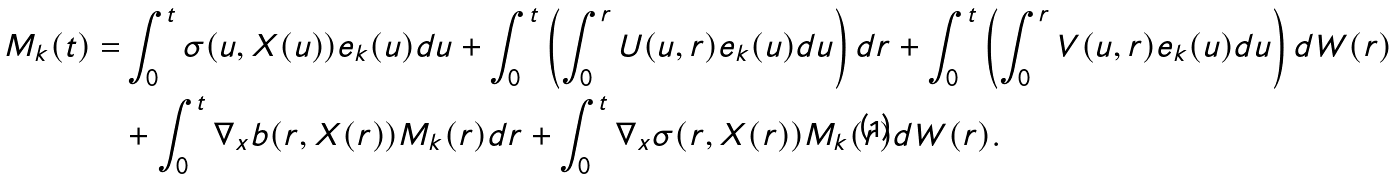<formula> <loc_0><loc_0><loc_500><loc_500>M _ { k } ( t ) = & \int _ { 0 } ^ { t } \sigma ( u , X ( u ) ) e _ { k } ( u ) d u + \int _ { 0 } ^ { t } \left ( \int _ { 0 } ^ { r } U ( u , r ) e _ { k } ( u ) d u \right ) d r + \int _ { 0 } ^ { t } \left ( \int _ { 0 } ^ { r } V ( u , r ) e _ { k } ( u ) d u \right ) d W ( r ) \\ & + \int _ { 0 } ^ { t } \nabla _ { x } b ( r , X ( r ) ) M _ { k } ( r ) d r + \int _ { 0 } ^ { t } \nabla _ { x } \sigma ( r , X ( r ) ) M _ { k } ( r ) d W ( r ) .</formula> 